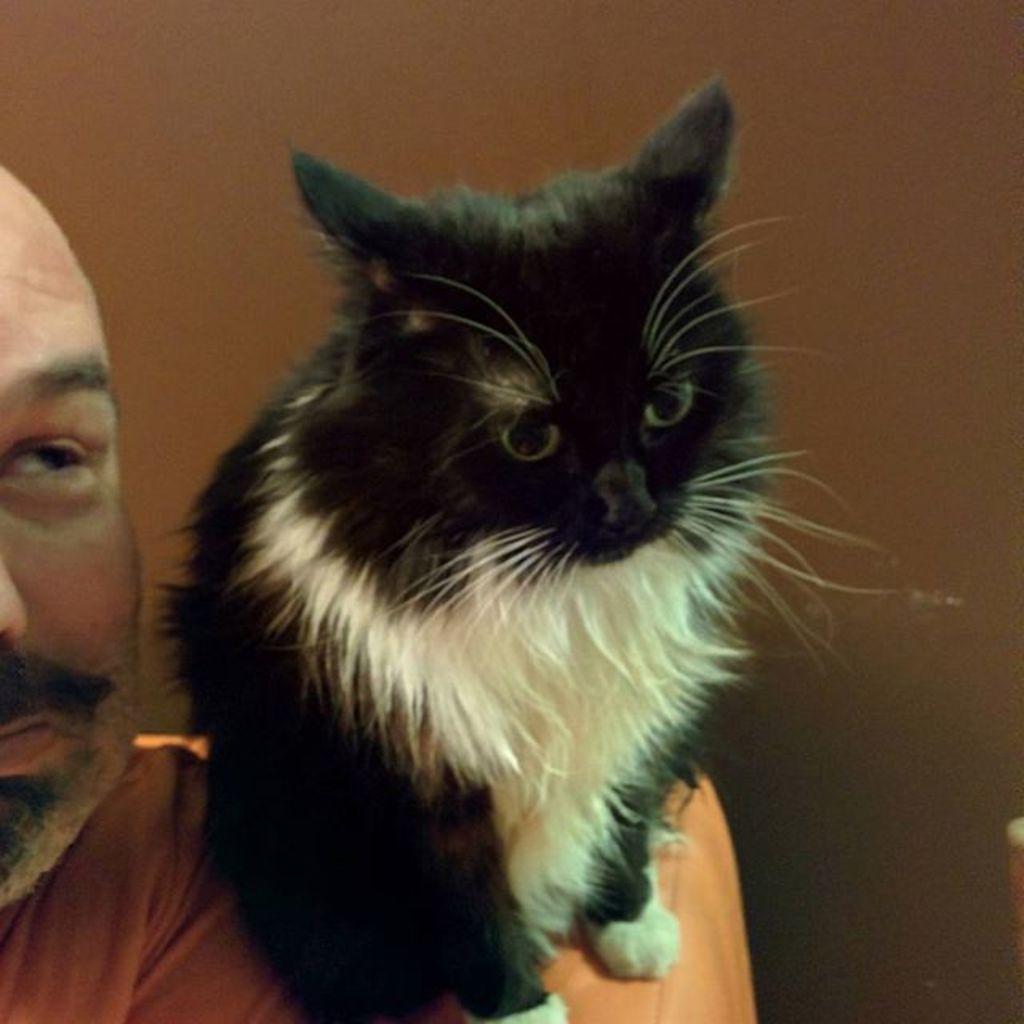Please provide a concise description of this image. There is a person. On his shoulder there is a black and white cat. In the back there is a wall. 